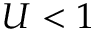Convert formula to latex. <formula><loc_0><loc_0><loc_500><loc_500>U < 1</formula> 